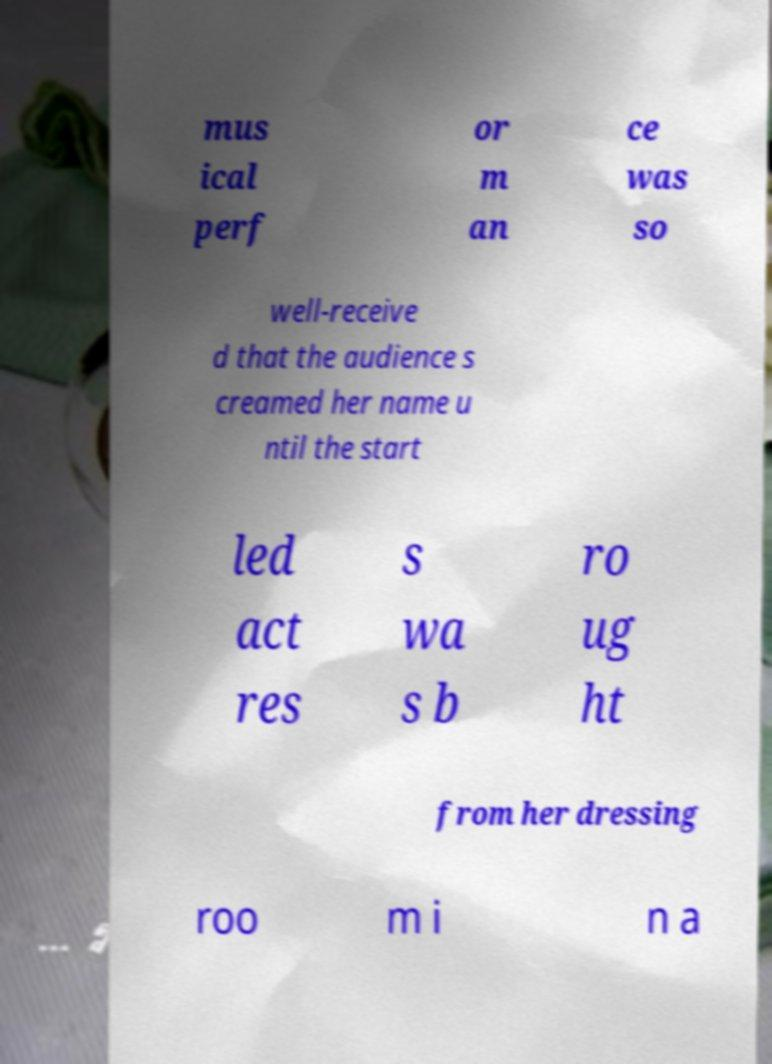Can you read and provide the text displayed in the image?This photo seems to have some interesting text. Can you extract and type it out for me? mus ical perf or m an ce was so well-receive d that the audience s creamed her name u ntil the start led act res s wa s b ro ug ht from her dressing roo m i n a 